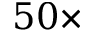<formula> <loc_0><loc_0><loc_500><loc_500>5 0 \times</formula> 